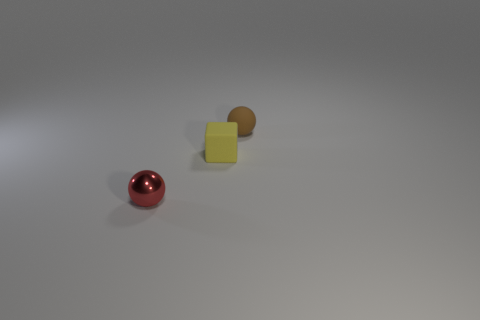What is the shape of the other object that is made of the same material as the small brown thing?
Provide a succinct answer. Cube. Are there more brown balls on the right side of the small yellow rubber cube than small spheres that are to the left of the small red metal object?
Your answer should be compact. Yes. How many rubber cubes are the same size as the matte ball?
Your answer should be compact. 1. Are there fewer tiny yellow objects in front of the red shiny ball than matte things that are in front of the small brown ball?
Your answer should be very brief. Yes. Are there any small red things of the same shape as the tiny brown thing?
Ensure brevity in your answer.  Yes. Is the tiny brown matte thing the same shape as the metallic thing?
Offer a very short reply. Yes. What number of tiny objects are either matte objects or brown rubber things?
Your answer should be compact. 2. Are there more small gray cubes than yellow rubber things?
Offer a terse response. No. There is a brown sphere that is made of the same material as the yellow object; what is its size?
Provide a short and direct response. Small. There is a object that is behind the yellow matte block; is it the same size as the sphere that is in front of the matte sphere?
Your answer should be compact. Yes. 